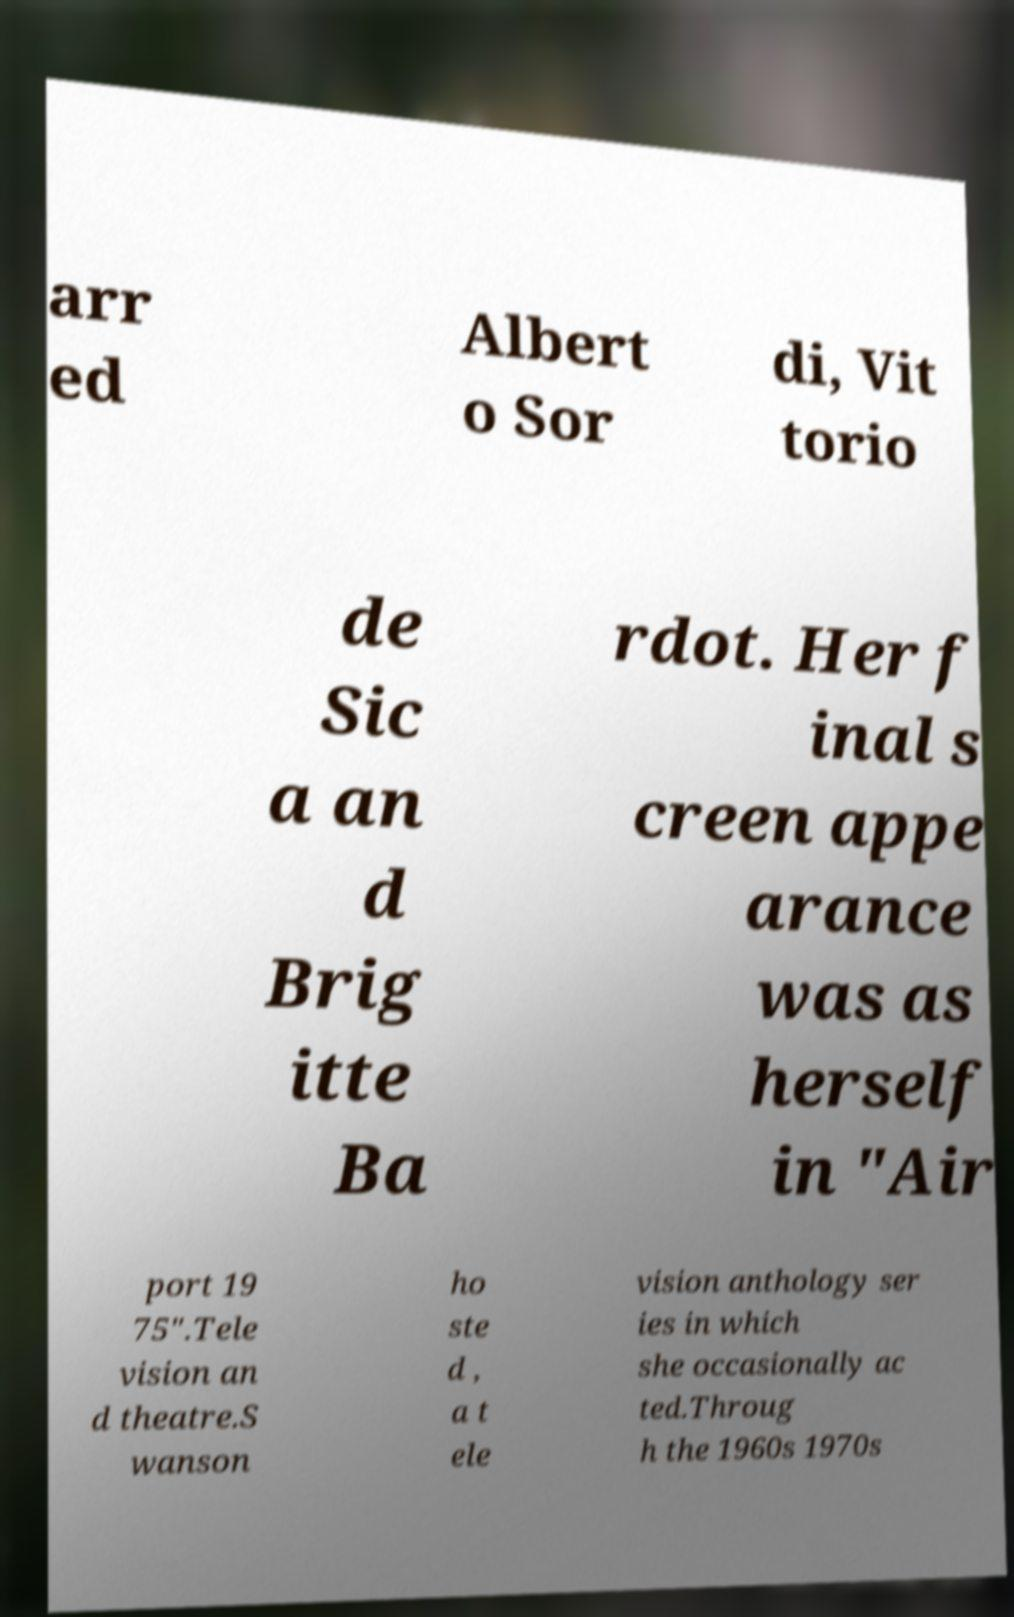Please read and relay the text visible in this image. What does it say? arr ed Albert o Sor di, Vit torio de Sic a an d Brig itte Ba rdot. Her f inal s creen appe arance was as herself in "Air port 19 75".Tele vision an d theatre.S wanson ho ste d , a t ele vision anthology ser ies in which she occasionally ac ted.Throug h the 1960s 1970s 